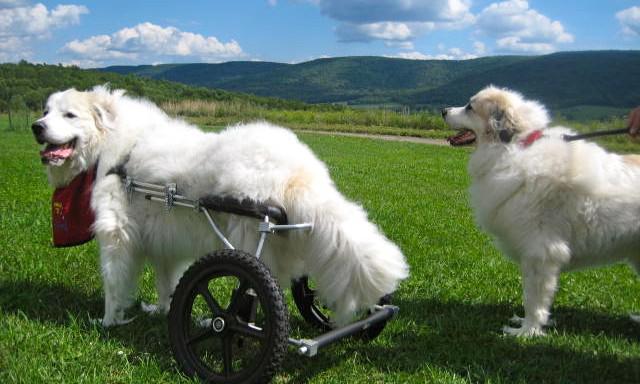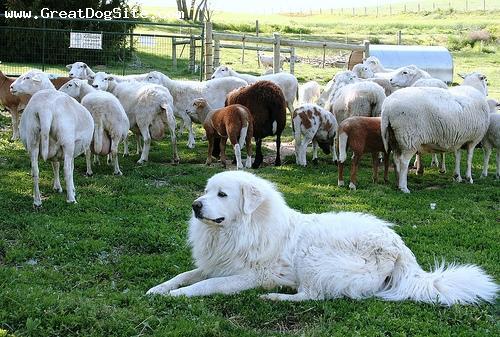The first image is the image on the left, the second image is the image on the right. For the images displayed, is the sentence "An animal in the image on the left has wheels." factually correct? Answer yes or no. Yes. 